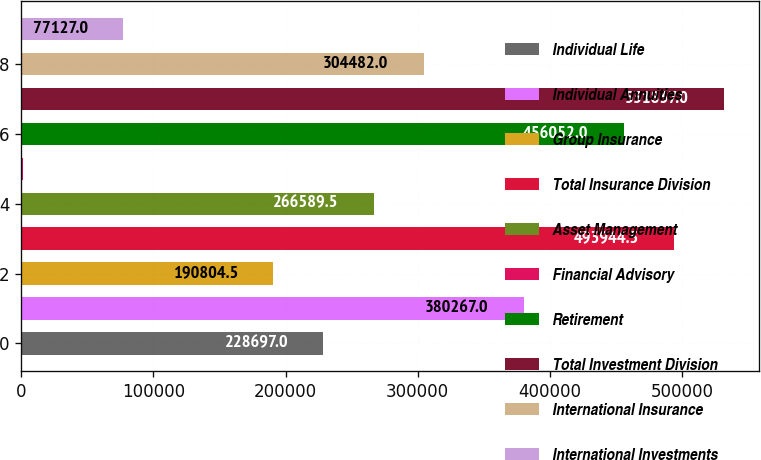Convert chart to OTSL. <chart><loc_0><loc_0><loc_500><loc_500><bar_chart><fcel>Individual Life<fcel>Individual Annuities<fcel>Group Insurance<fcel>Total Insurance Division<fcel>Asset Management<fcel>Financial Advisory<fcel>Retirement<fcel>Total Investment Division<fcel>International Insurance<fcel>International Investments<nl><fcel>228697<fcel>380267<fcel>190804<fcel>493944<fcel>266590<fcel>1342<fcel>456052<fcel>531837<fcel>304482<fcel>77127<nl></chart> 